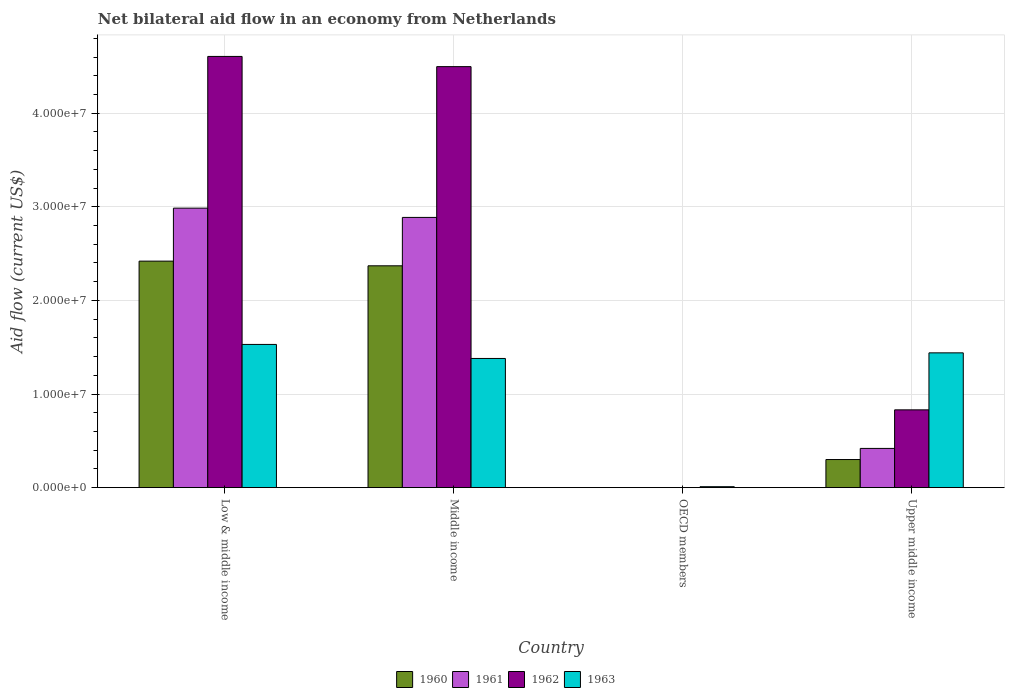Are the number of bars per tick equal to the number of legend labels?
Offer a very short reply. No. How many bars are there on the 2nd tick from the right?
Ensure brevity in your answer.  1. What is the label of the 4th group of bars from the left?
Provide a succinct answer. Upper middle income. In how many cases, is the number of bars for a given country not equal to the number of legend labels?
Keep it short and to the point. 1. What is the net bilateral aid flow in 1960 in Middle income?
Keep it short and to the point. 2.37e+07. Across all countries, what is the maximum net bilateral aid flow in 1960?
Offer a very short reply. 2.42e+07. Across all countries, what is the minimum net bilateral aid flow in 1962?
Provide a short and direct response. 0. What is the total net bilateral aid flow in 1961 in the graph?
Offer a very short reply. 6.29e+07. What is the difference between the net bilateral aid flow in 1963 in Middle income and that in Upper middle income?
Offer a very short reply. -6.00e+05. What is the difference between the net bilateral aid flow in 1962 in Middle income and the net bilateral aid flow in 1963 in Upper middle income?
Offer a terse response. 3.06e+07. What is the average net bilateral aid flow in 1960 per country?
Ensure brevity in your answer.  1.27e+07. What is the difference between the net bilateral aid flow of/in 1961 and net bilateral aid flow of/in 1960 in Middle income?
Give a very brief answer. 5.17e+06. What is the ratio of the net bilateral aid flow in 1962 in Low & middle income to that in Upper middle income?
Your answer should be very brief. 5.54. Is the net bilateral aid flow in 1963 in Low & middle income less than that in Upper middle income?
Provide a succinct answer. No. Is the difference between the net bilateral aid flow in 1961 in Low & middle income and Middle income greater than the difference between the net bilateral aid flow in 1960 in Low & middle income and Middle income?
Keep it short and to the point. Yes. What is the difference between the highest and the lowest net bilateral aid flow in 1962?
Your answer should be very brief. 4.61e+07. In how many countries, is the net bilateral aid flow in 1960 greater than the average net bilateral aid flow in 1960 taken over all countries?
Your response must be concise. 2. Is the sum of the net bilateral aid flow in 1961 in Low & middle income and Upper middle income greater than the maximum net bilateral aid flow in 1962 across all countries?
Give a very brief answer. No. Is it the case that in every country, the sum of the net bilateral aid flow in 1963 and net bilateral aid flow in 1961 is greater than the net bilateral aid flow in 1960?
Provide a short and direct response. Yes. How many bars are there?
Your response must be concise. 13. Are all the bars in the graph horizontal?
Offer a terse response. No. What is the difference between two consecutive major ticks on the Y-axis?
Your answer should be very brief. 1.00e+07. Does the graph contain any zero values?
Give a very brief answer. Yes. How are the legend labels stacked?
Your answer should be compact. Horizontal. What is the title of the graph?
Your answer should be compact. Net bilateral aid flow in an economy from Netherlands. What is the label or title of the Y-axis?
Offer a terse response. Aid flow (current US$). What is the Aid flow (current US$) in 1960 in Low & middle income?
Your answer should be very brief. 2.42e+07. What is the Aid flow (current US$) in 1961 in Low & middle income?
Your answer should be very brief. 2.99e+07. What is the Aid flow (current US$) in 1962 in Low & middle income?
Provide a succinct answer. 4.61e+07. What is the Aid flow (current US$) in 1963 in Low & middle income?
Provide a succinct answer. 1.53e+07. What is the Aid flow (current US$) of 1960 in Middle income?
Offer a very short reply. 2.37e+07. What is the Aid flow (current US$) in 1961 in Middle income?
Offer a terse response. 2.89e+07. What is the Aid flow (current US$) of 1962 in Middle income?
Ensure brevity in your answer.  4.50e+07. What is the Aid flow (current US$) in 1963 in Middle income?
Give a very brief answer. 1.38e+07. What is the Aid flow (current US$) of 1960 in OECD members?
Offer a very short reply. 0. What is the Aid flow (current US$) in 1961 in Upper middle income?
Your answer should be compact. 4.19e+06. What is the Aid flow (current US$) in 1962 in Upper middle income?
Offer a terse response. 8.31e+06. What is the Aid flow (current US$) of 1963 in Upper middle income?
Provide a succinct answer. 1.44e+07. Across all countries, what is the maximum Aid flow (current US$) of 1960?
Give a very brief answer. 2.42e+07. Across all countries, what is the maximum Aid flow (current US$) of 1961?
Ensure brevity in your answer.  2.99e+07. Across all countries, what is the maximum Aid flow (current US$) of 1962?
Offer a terse response. 4.61e+07. Across all countries, what is the maximum Aid flow (current US$) in 1963?
Make the answer very short. 1.53e+07. Across all countries, what is the minimum Aid flow (current US$) of 1961?
Your answer should be very brief. 0. Across all countries, what is the minimum Aid flow (current US$) in 1963?
Offer a terse response. 1.00e+05. What is the total Aid flow (current US$) of 1960 in the graph?
Your answer should be compact. 5.09e+07. What is the total Aid flow (current US$) in 1961 in the graph?
Offer a terse response. 6.29e+07. What is the total Aid flow (current US$) of 1962 in the graph?
Make the answer very short. 9.94e+07. What is the total Aid flow (current US$) in 1963 in the graph?
Make the answer very short. 4.36e+07. What is the difference between the Aid flow (current US$) in 1961 in Low & middle income and that in Middle income?
Your answer should be very brief. 9.90e+05. What is the difference between the Aid flow (current US$) of 1962 in Low & middle income and that in Middle income?
Your answer should be compact. 1.09e+06. What is the difference between the Aid flow (current US$) in 1963 in Low & middle income and that in Middle income?
Your response must be concise. 1.50e+06. What is the difference between the Aid flow (current US$) of 1963 in Low & middle income and that in OECD members?
Offer a very short reply. 1.52e+07. What is the difference between the Aid flow (current US$) in 1960 in Low & middle income and that in Upper middle income?
Ensure brevity in your answer.  2.12e+07. What is the difference between the Aid flow (current US$) in 1961 in Low & middle income and that in Upper middle income?
Offer a terse response. 2.57e+07. What is the difference between the Aid flow (current US$) of 1962 in Low & middle income and that in Upper middle income?
Ensure brevity in your answer.  3.78e+07. What is the difference between the Aid flow (current US$) in 1963 in Low & middle income and that in Upper middle income?
Offer a terse response. 9.00e+05. What is the difference between the Aid flow (current US$) in 1963 in Middle income and that in OECD members?
Provide a succinct answer. 1.37e+07. What is the difference between the Aid flow (current US$) of 1960 in Middle income and that in Upper middle income?
Provide a short and direct response. 2.07e+07. What is the difference between the Aid flow (current US$) of 1961 in Middle income and that in Upper middle income?
Offer a terse response. 2.47e+07. What is the difference between the Aid flow (current US$) in 1962 in Middle income and that in Upper middle income?
Your answer should be very brief. 3.67e+07. What is the difference between the Aid flow (current US$) in 1963 in Middle income and that in Upper middle income?
Provide a succinct answer. -6.00e+05. What is the difference between the Aid flow (current US$) of 1963 in OECD members and that in Upper middle income?
Provide a succinct answer. -1.43e+07. What is the difference between the Aid flow (current US$) in 1960 in Low & middle income and the Aid flow (current US$) in 1961 in Middle income?
Provide a succinct answer. -4.67e+06. What is the difference between the Aid flow (current US$) of 1960 in Low & middle income and the Aid flow (current US$) of 1962 in Middle income?
Offer a terse response. -2.08e+07. What is the difference between the Aid flow (current US$) of 1960 in Low & middle income and the Aid flow (current US$) of 1963 in Middle income?
Make the answer very short. 1.04e+07. What is the difference between the Aid flow (current US$) in 1961 in Low & middle income and the Aid flow (current US$) in 1962 in Middle income?
Ensure brevity in your answer.  -1.51e+07. What is the difference between the Aid flow (current US$) of 1961 in Low & middle income and the Aid flow (current US$) of 1963 in Middle income?
Provide a short and direct response. 1.61e+07. What is the difference between the Aid flow (current US$) in 1962 in Low & middle income and the Aid flow (current US$) in 1963 in Middle income?
Your response must be concise. 3.23e+07. What is the difference between the Aid flow (current US$) in 1960 in Low & middle income and the Aid flow (current US$) in 1963 in OECD members?
Provide a short and direct response. 2.41e+07. What is the difference between the Aid flow (current US$) in 1961 in Low & middle income and the Aid flow (current US$) in 1963 in OECD members?
Give a very brief answer. 2.98e+07. What is the difference between the Aid flow (current US$) in 1962 in Low & middle income and the Aid flow (current US$) in 1963 in OECD members?
Provide a short and direct response. 4.60e+07. What is the difference between the Aid flow (current US$) in 1960 in Low & middle income and the Aid flow (current US$) in 1961 in Upper middle income?
Keep it short and to the point. 2.00e+07. What is the difference between the Aid flow (current US$) in 1960 in Low & middle income and the Aid flow (current US$) in 1962 in Upper middle income?
Make the answer very short. 1.59e+07. What is the difference between the Aid flow (current US$) of 1960 in Low & middle income and the Aid flow (current US$) of 1963 in Upper middle income?
Offer a terse response. 9.80e+06. What is the difference between the Aid flow (current US$) in 1961 in Low & middle income and the Aid flow (current US$) in 1962 in Upper middle income?
Offer a terse response. 2.16e+07. What is the difference between the Aid flow (current US$) in 1961 in Low & middle income and the Aid flow (current US$) in 1963 in Upper middle income?
Your answer should be compact. 1.55e+07. What is the difference between the Aid flow (current US$) of 1962 in Low & middle income and the Aid flow (current US$) of 1963 in Upper middle income?
Keep it short and to the point. 3.17e+07. What is the difference between the Aid flow (current US$) in 1960 in Middle income and the Aid flow (current US$) in 1963 in OECD members?
Offer a terse response. 2.36e+07. What is the difference between the Aid flow (current US$) of 1961 in Middle income and the Aid flow (current US$) of 1963 in OECD members?
Your answer should be very brief. 2.88e+07. What is the difference between the Aid flow (current US$) of 1962 in Middle income and the Aid flow (current US$) of 1963 in OECD members?
Keep it short and to the point. 4.49e+07. What is the difference between the Aid flow (current US$) in 1960 in Middle income and the Aid flow (current US$) in 1961 in Upper middle income?
Offer a terse response. 1.95e+07. What is the difference between the Aid flow (current US$) in 1960 in Middle income and the Aid flow (current US$) in 1962 in Upper middle income?
Offer a very short reply. 1.54e+07. What is the difference between the Aid flow (current US$) in 1960 in Middle income and the Aid flow (current US$) in 1963 in Upper middle income?
Your answer should be very brief. 9.30e+06. What is the difference between the Aid flow (current US$) of 1961 in Middle income and the Aid flow (current US$) of 1962 in Upper middle income?
Your response must be concise. 2.06e+07. What is the difference between the Aid flow (current US$) in 1961 in Middle income and the Aid flow (current US$) in 1963 in Upper middle income?
Offer a terse response. 1.45e+07. What is the difference between the Aid flow (current US$) of 1962 in Middle income and the Aid flow (current US$) of 1963 in Upper middle income?
Make the answer very short. 3.06e+07. What is the average Aid flow (current US$) in 1960 per country?
Your answer should be compact. 1.27e+07. What is the average Aid flow (current US$) in 1961 per country?
Ensure brevity in your answer.  1.57e+07. What is the average Aid flow (current US$) in 1962 per country?
Make the answer very short. 2.48e+07. What is the average Aid flow (current US$) of 1963 per country?
Your answer should be compact. 1.09e+07. What is the difference between the Aid flow (current US$) in 1960 and Aid flow (current US$) in 1961 in Low & middle income?
Offer a very short reply. -5.66e+06. What is the difference between the Aid flow (current US$) of 1960 and Aid flow (current US$) of 1962 in Low & middle income?
Give a very brief answer. -2.19e+07. What is the difference between the Aid flow (current US$) in 1960 and Aid flow (current US$) in 1963 in Low & middle income?
Your response must be concise. 8.90e+06. What is the difference between the Aid flow (current US$) in 1961 and Aid flow (current US$) in 1962 in Low & middle income?
Your answer should be very brief. -1.62e+07. What is the difference between the Aid flow (current US$) of 1961 and Aid flow (current US$) of 1963 in Low & middle income?
Your answer should be compact. 1.46e+07. What is the difference between the Aid flow (current US$) in 1962 and Aid flow (current US$) in 1963 in Low & middle income?
Offer a very short reply. 3.08e+07. What is the difference between the Aid flow (current US$) of 1960 and Aid flow (current US$) of 1961 in Middle income?
Make the answer very short. -5.17e+06. What is the difference between the Aid flow (current US$) of 1960 and Aid flow (current US$) of 1962 in Middle income?
Your response must be concise. -2.13e+07. What is the difference between the Aid flow (current US$) in 1960 and Aid flow (current US$) in 1963 in Middle income?
Your answer should be very brief. 9.90e+06. What is the difference between the Aid flow (current US$) of 1961 and Aid flow (current US$) of 1962 in Middle income?
Your answer should be very brief. -1.61e+07. What is the difference between the Aid flow (current US$) of 1961 and Aid flow (current US$) of 1963 in Middle income?
Your response must be concise. 1.51e+07. What is the difference between the Aid flow (current US$) of 1962 and Aid flow (current US$) of 1963 in Middle income?
Give a very brief answer. 3.12e+07. What is the difference between the Aid flow (current US$) in 1960 and Aid flow (current US$) in 1961 in Upper middle income?
Provide a short and direct response. -1.19e+06. What is the difference between the Aid flow (current US$) of 1960 and Aid flow (current US$) of 1962 in Upper middle income?
Offer a terse response. -5.31e+06. What is the difference between the Aid flow (current US$) of 1960 and Aid flow (current US$) of 1963 in Upper middle income?
Provide a succinct answer. -1.14e+07. What is the difference between the Aid flow (current US$) of 1961 and Aid flow (current US$) of 1962 in Upper middle income?
Provide a short and direct response. -4.12e+06. What is the difference between the Aid flow (current US$) in 1961 and Aid flow (current US$) in 1963 in Upper middle income?
Provide a short and direct response. -1.02e+07. What is the difference between the Aid flow (current US$) of 1962 and Aid flow (current US$) of 1963 in Upper middle income?
Keep it short and to the point. -6.09e+06. What is the ratio of the Aid flow (current US$) of 1960 in Low & middle income to that in Middle income?
Keep it short and to the point. 1.02. What is the ratio of the Aid flow (current US$) in 1961 in Low & middle income to that in Middle income?
Keep it short and to the point. 1.03. What is the ratio of the Aid flow (current US$) in 1962 in Low & middle income to that in Middle income?
Provide a succinct answer. 1.02. What is the ratio of the Aid flow (current US$) in 1963 in Low & middle income to that in Middle income?
Make the answer very short. 1.11. What is the ratio of the Aid flow (current US$) in 1963 in Low & middle income to that in OECD members?
Offer a very short reply. 153. What is the ratio of the Aid flow (current US$) of 1960 in Low & middle income to that in Upper middle income?
Offer a very short reply. 8.07. What is the ratio of the Aid flow (current US$) of 1961 in Low & middle income to that in Upper middle income?
Keep it short and to the point. 7.13. What is the ratio of the Aid flow (current US$) in 1962 in Low & middle income to that in Upper middle income?
Keep it short and to the point. 5.54. What is the ratio of the Aid flow (current US$) in 1963 in Low & middle income to that in Upper middle income?
Offer a terse response. 1.06. What is the ratio of the Aid flow (current US$) in 1963 in Middle income to that in OECD members?
Give a very brief answer. 138. What is the ratio of the Aid flow (current US$) in 1960 in Middle income to that in Upper middle income?
Give a very brief answer. 7.9. What is the ratio of the Aid flow (current US$) of 1961 in Middle income to that in Upper middle income?
Offer a very short reply. 6.89. What is the ratio of the Aid flow (current US$) in 1962 in Middle income to that in Upper middle income?
Keep it short and to the point. 5.41. What is the ratio of the Aid flow (current US$) in 1963 in Middle income to that in Upper middle income?
Offer a terse response. 0.96. What is the ratio of the Aid flow (current US$) of 1963 in OECD members to that in Upper middle income?
Your response must be concise. 0.01. What is the difference between the highest and the second highest Aid flow (current US$) of 1961?
Your answer should be very brief. 9.90e+05. What is the difference between the highest and the second highest Aid flow (current US$) in 1962?
Ensure brevity in your answer.  1.09e+06. What is the difference between the highest and the second highest Aid flow (current US$) in 1963?
Provide a short and direct response. 9.00e+05. What is the difference between the highest and the lowest Aid flow (current US$) in 1960?
Ensure brevity in your answer.  2.42e+07. What is the difference between the highest and the lowest Aid flow (current US$) in 1961?
Your answer should be very brief. 2.99e+07. What is the difference between the highest and the lowest Aid flow (current US$) in 1962?
Give a very brief answer. 4.61e+07. What is the difference between the highest and the lowest Aid flow (current US$) of 1963?
Give a very brief answer. 1.52e+07. 